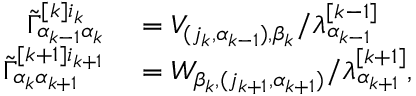Convert formula to latex. <formula><loc_0><loc_0><loc_500><loc_500>\begin{array} { r l } { \tilde { \Gamma } _ { \alpha _ { k - 1 } \alpha _ { k } } ^ { [ k ] i _ { k } } } & = V _ { ( j _ { k } , \alpha _ { k - 1 } ) , \beta _ { k } } / \lambda _ { \alpha _ { k - 1 } } ^ { [ k - 1 ] } } \\ { \tilde { \Gamma } _ { \alpha _ { k } \alpha _ { k + 1 } } ^ { [ k + 1 ] i _ { k + 1 } } } & = W _ { \beta _ { k } , ( j _ { k + 1 } , \alpha _ { k + 1 } ) } / \lambda _ { \alpha _ { k + 1 } } ^ { [ k + 1 ] } , } \end{array}</formula> 